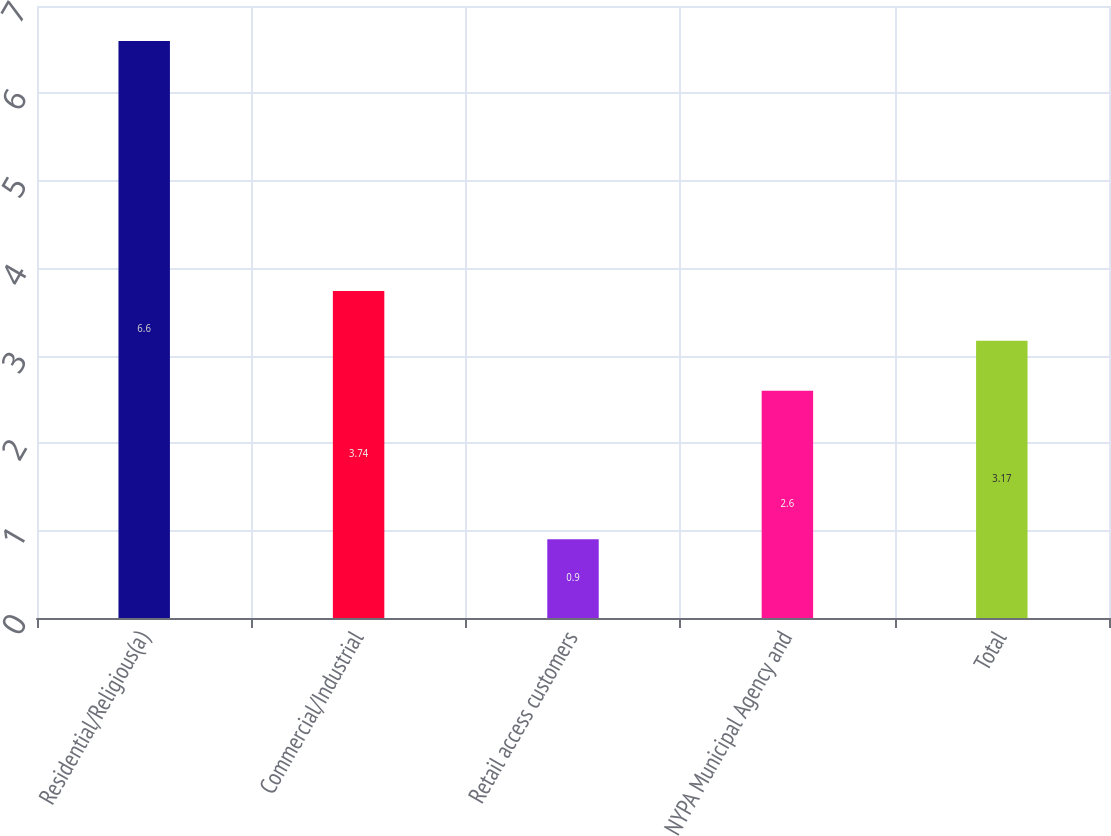Convert chart to OTSL. <chart><loc_0><loc_0><loc_500><loc_500><bar_chart><fcel>Residential/Religious(a)<fcel>Commercial/Industrial<fcel>Retail access customers<fcel>NYPA Municipal Agency and<fcel>Total<nl><fcel>6.6<fcel>3.74<fcel>0.9<fcel>2.6<fcel>3.17<nl></chart> 